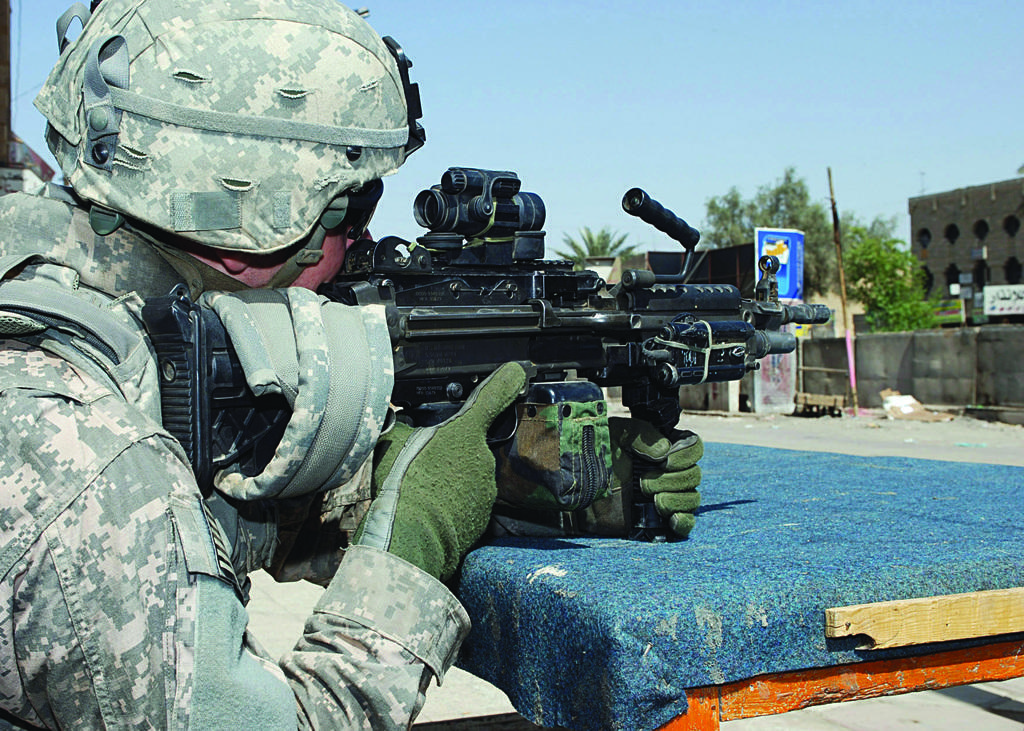In one or two sentences, can you explain what this image depicts? In this image I see a person who is wearing uniform and I see that this person is holding a gun in hands and I see the table on which there is blue color cloth. In the background I see the wall and I see the trees and I see the blue sky. 